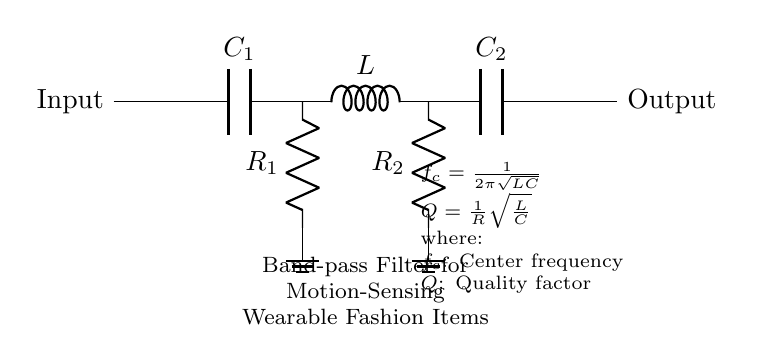What type of filter is depicted in this circuit? The circuit diagram is labeled as a "Band-pass Filter," indicating that it is designed to allow signals within a certain frequency range to pass while attenuating frequencies outside of this range.
Answer: Band-pass filter What components are used in the given filter circuit? The circuit shows a capacitor, an inductor, and two resistors, labeled as C1, L, C2, R1, and R2, which are standard components in band-pass filters.
Answer: Capacitor, inductor, resistors What is the role of the inductor in this circuit? The inductor in the band-pass filter plays a crucial role in determining the filter's frequency response along with capacitors, allowing a specific range of frequencies to pass based on its inductance.
Answer: Frequency response What is the center frequency formula in this circuit? The circuit provides the formula for calculating the center frequency, which is given as f_c = 1/(2π√(LC)). This indicates the frequency at which the circuit will allow signals to pass most effectively.
Answer: f_c = 1/(2π√(LC)) How does the Quality factor Q impact this filter? The Quality factor Q is calculated as Q = 1/R * √(L/C), indicating the selectivity and performance of the filter. A higher Q means a narrower bandwidth around the center frequency, which is crucial for precise applications like motion sensing in wearables.
Answer: Q = 1/R * √(L/C) What do the resistor R1 and R2 represent in this circuit? The resistors R1 and R2 in the circuit are essential for determining the damping and overall response of the filter, impacting how quickly the filter responds to frequency changes and its bandwidth.
Answer: Damping 